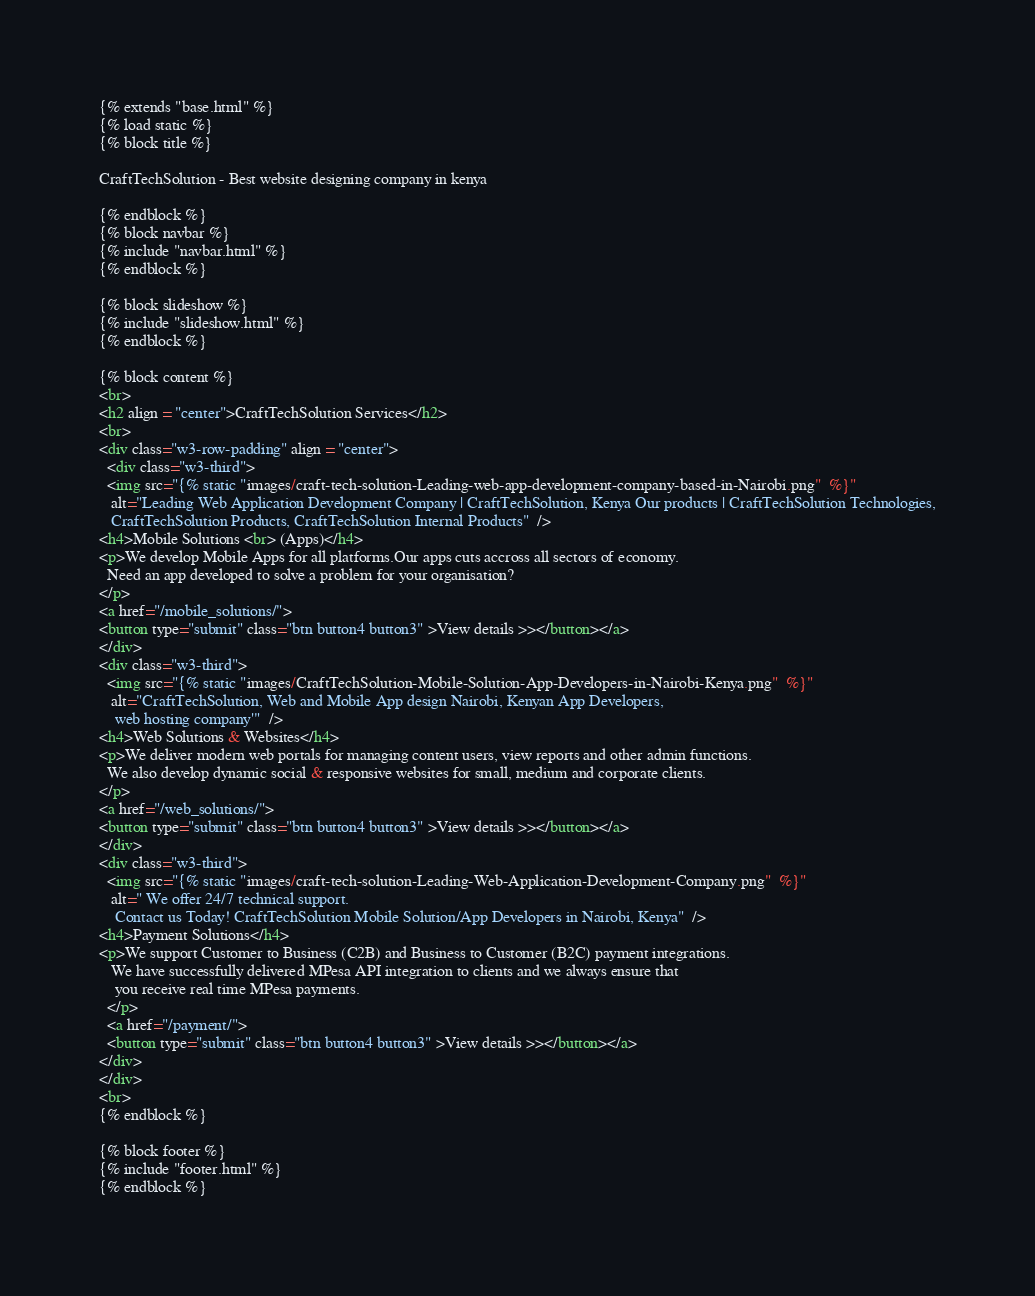Convert code to text. <code><loc_0><loc_0><loc_500><loc_500><_HTML_>{% extends "base.html" %}
{% load static %}
{% block title %}

CraftTechSolution - Best website designing company in kenya

{% endblock %}
{% block navbar %}
{% include "navbar.html" %}
{% endblock %}

{% block slideshow %}
{% include "slideshow.html" %}
{% endblock %}

{% block content %}
<br>
<h2 align = "center">CraftTechSolution Services</h2>
<br>
<div class="w3-row-padding" align = "center">
  <div class="w3-third">
  <img src="{% static "images/craft-tech-solution-Leading-web-app-development-company-based-in-Nairobi.png"  %}"
   alt="Leading Web Application Development Company | CraftTechSolution, Kenya Our products | CraftTechSolution Technologies,
   CraftTechSolution Products, CraftTechSolution Internal Products"  />
<h4>Mobile Solutions <br> (Apps)</h4>
<p>We develop Mobile Apps for all platforms.Our apps cuts accross all sectors of economy.
  Need an app developed to solve a problem for your organisation?
</p>
<a href="/mobile_solutions/">
<button type="submit" class="btn button4 button3" >View details >></button></a>
</div>
<div class="w3-third">
  <img src="{% static "images/CraftTechSolution-Mobile-Solution-App-Developers-in-Nairobi-Kenya.png"  %}"
   alt="CraftTechSolution, Web and Mobile App design Nairobi, Kenyan App Developers,
    web hosting company'"  />
<h4>Web Solutions & Websites</h4>
<p>We deliver modern web portals for managing content users, view reports and other admin functions.
  We also develop dynamic social & responsive websites for small, medium and corporate clients.
</p>
<a href="/web_solutions/">
<button type="submit" class="btn button4 button3" >View details >></button></a>
</div>
<div class="w3-third">
  <img src="{% static "images/craft-tech-solution-Leading-Web-Application-Development-Company.png"  %}"
   alt=" We offer 24/7 technical support.
    Contact us Today! CraftTechSolution Mobile Solution/App Developers in Nairobi, Kenya"  />
<h4>Payment Solutions</h4>
<p>We support Customer to Business (C2B) and Business to Customer (B2C) payment integrations.
   We have successfully delivered MPesa API integration to clients and we always ensure that
    you receive real time MPesa payments.
  </p>
  <a href="/payment/">
  <button type="submit" class="btn button4 button3" >View details >></button></a>
</div>
</div>
<br>
{% endblock %}

{% block footer %}
{% include "footer.html" %}
{% endblock %}
</code> 